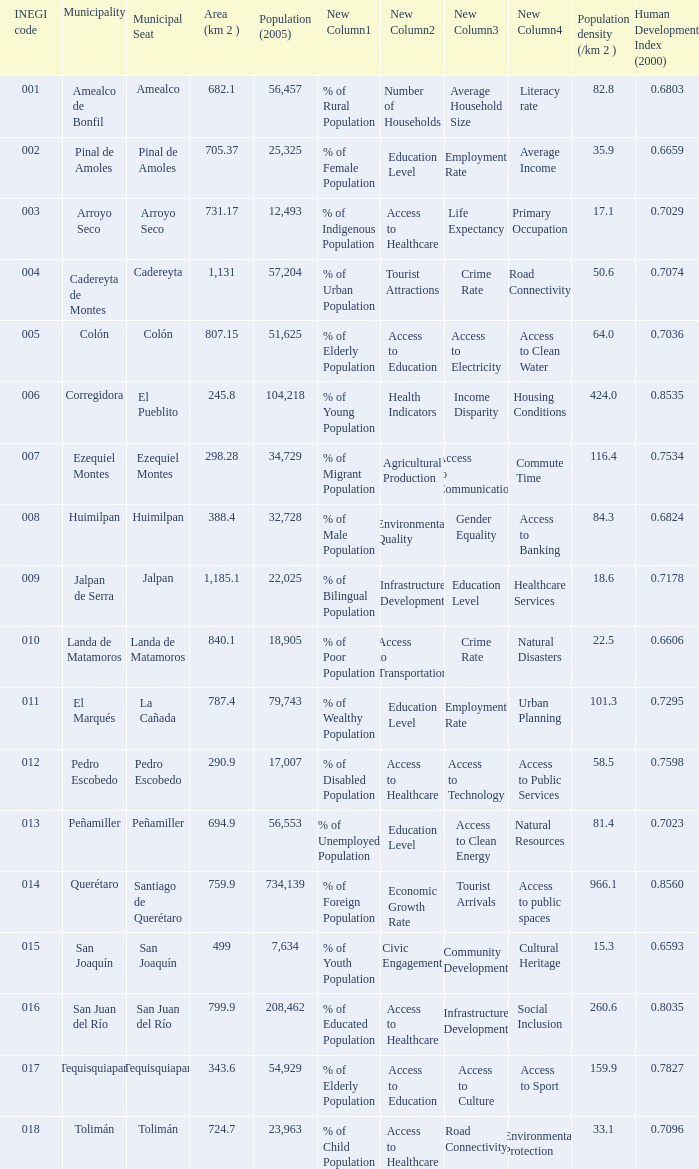Which Area (km 2 )has a Population (2005) of 57,204, and a Human Development Index (2000) smaller than 0.7074? 0.0. Give me the full table as a dictionary. {'header': ['INEGI code', 'Municipality', 'Municipal Seat', 'Area (km 2 )', 'Population (2005)', 'New Column1', 'New Column2', 'New Column3', 'New Column4', 'Population density (/km 2 )', 'Human Development Index (2000)'], 'rows': [['001', 'Amealco de Bonfil', 'Amealco', '682.1', '56,457', '% of Rural Population', 'Number of Households', 'Average Household Size', 'Literacy rate', '82.8', '0.6803'], ['002', 'Pinal de Amoles', 'Pinal de Amoles', '705.37', '25,325', '% of Female Population', 'Education Level', 'Employment Rate', 'Average Income', '35.9', '0.6659'], ['003', 'Arroyo Seco', 'Arroyo Seco', '731.17', '12,493', '% of Indigenous Population', 'Access to Healthcare', 'Life Expectancy', 'Primary Occupation', '17.1', '0.7029'], ['004', 'Cadereyta de Montes', 'Cadereyta', '1,131', '57,204', '% of Urban Population', 'Tourist Attractions', 'Crime Rate', 'Road Connectivity', '50.6', '0.7074'], ['005', 'Colón', 'Colón', '807.15', '51,625', '% of Elderly Population', 'Access to Education', 'Access to Electricity', 'Access to Clean Water', '64.0', '0.7036'], ['006', 'Corregidora', 'El Pueblito', '245.8', '104,218', '% of Young Population', 'Health Indicators', 'Income Disparity', 'Housing Conditions', '424.0', '0.8535'], ['007', 'Ezequiel Montes', 'Ezequiel Montes', '298.28', '34,729', '% of Migrant Population', 'Agricultural Production', 'Access to Communication', 'Commute Time', '116.4', '0.7534'], ['008', 'Huimilpan', 'Huimilpan', '388.4', '32,728', '% of Male Population', 'Environmental Quality', 'Gender Equality', 'Access to Banking', '84.3', '0.6824'], ['009', 'Jalpan de Serra', 'Jalpan', '1,185.1', '22,025', '% of Bilingual Population', 'Infrastructure Development', 'Education Level', 'Healthcare Services', '18.6', '0.7178'], ['010', 'Landa de Matamoros', 'Landa de Matamoros', '840.1', '18,905', '% of Poor Population', 'Access to Transportation', 'Crime Rate', 'Natural Disasters', '22.5', '0.6606'], ['011', 'El Marqués', 'La Cañada', '787.4', '79,743', '% of Wealthy Population', 'Education Level', 'Employment Rate', 'Urban Planning', '101.3', '0.7295'], ['012', 'Pedro Escobedo', 'Pedro Escobedo', '290.9', '17,007', '% of Disabled Population', 'Access to Healthcare', 'Access to Technology', 'Access to Public Services', '58.5', '0.7598'], ['013', 'Peñamiller', 'Peñamiller', '694.9', '56,553', '% of Unemployed Population', 'Education Level', 'Access to Clean Energy', 'Natural Resources', '81.4', '0.7023'], ['014', 'Querétaro', 'Santiago de Querétaro', '759.9', '734,139', '% of Foreign Population', 'Economic Growth Rate', 'Tourist Arrivals', 'Access to public spaces', '966.1', '0.8560'], ['015', 'San Joaquín', 'San Joaquín', '499', '7,634', '% of Youth Population', 'Civic Engagement', 'Community Development', 'Cultural Heritage', '15.3', '0.6593'], ['016', 'San Juan del Río', 'San Juan del Río', '799.9', '208,462', '% of Educated Population', 'Access to Healthcare', 'Infrastructure Development', 'Social Inclusion', '260.6', '0.8035'], ['017', 'Tequisquiapan', 'Tequisquiapan', '343.6', '54,929', '% of Elderly Population', 'Access to Education', 'Access to Culture', 'Access to Sport', '159.9', '0.7827'], ['018', 'Tolimán', 'Tolimán', '724.7', '23,963', '% of Child Population', 'Access to Healthcare', 'Road Connectivity', 'Environmental Protection', '33.1', '0.7096']]} 